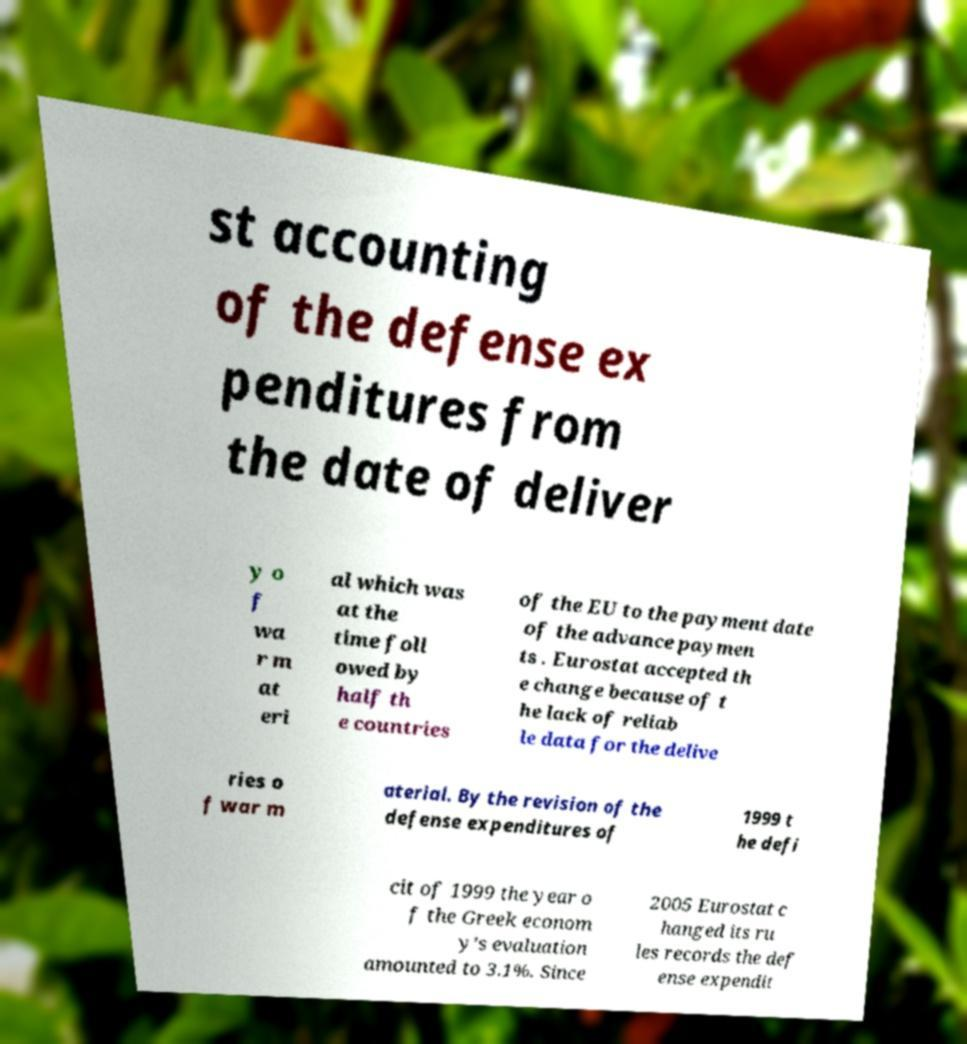Can you read and provide the text displayed in the image?This photo seems to have some interesting text. Can you extract and type it out for me? st accounting of the defense ex penditures from the date of deliver y o f wa r m at eri al which was at the time foll owed by half th e countries of the EU to the payment date of the advance paymen ts . Eurostat accepted th e change because of t he lack of reliab le data for the delive ries o f war m aterial. By the revision of the defense expenditures of 1999 t he defi cit of 1999 the year o f the Greek econom y’s evaluation amounted to 3.1%. Since 2005 Eurostat c hanged its ru les records the def ense expendit 